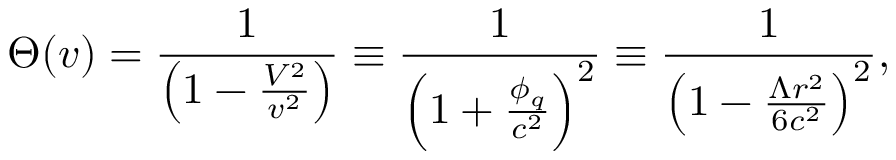<formula> <loc_0><loc_0><loc_500><loc_500>\Theta ( v ) = \frac { 1 } { \left ( 1 - \frac { V ^ { 2 } } { v ^ { 2 } } \right ) } \equiv \frac { 1 } { \left ( 1 + \frac { \phi _ { q } } { c ^ { 2 } } \right ) ^ { 2 } } \equiv \frac { 1 } { \left ( 1 - \frac { \Lambda r ^ { 2 } } { 6 c ^ { 2 } } \right ) ^ { 2 } } ,</formula> 